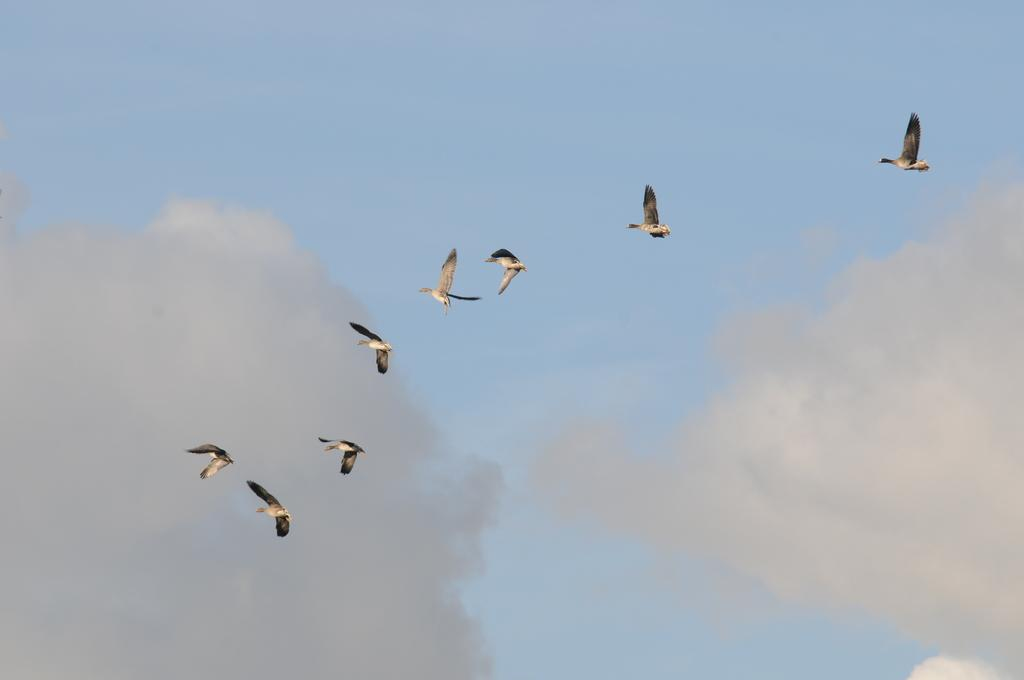What is happening in the sky in the image? There are birds flying in the sky. What else can be seen in the sky besides the birds? There are clouds visible in the sky. What type of poison is being used by the birds in the image? There is no poison present in the image; the birds are simply flying in the sky. 